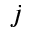<formula> <loc_0><loc_0><loc_500><loc_500>j</formula> 